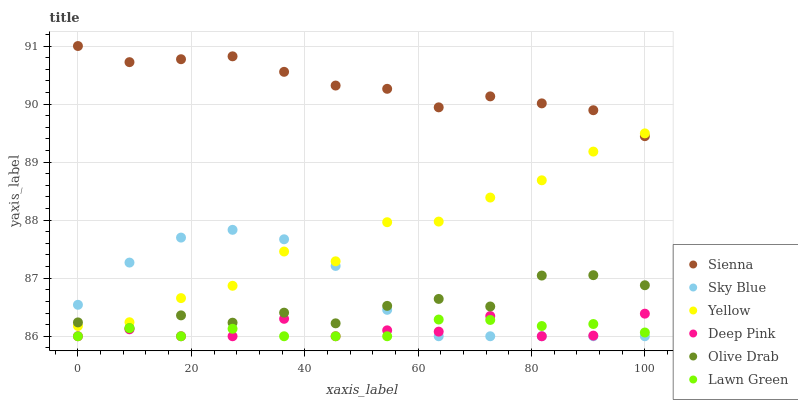Does Deep Pink have the minimum area under the curve?
Answer yes or no. Yes. Does Sienna have the maximum area under the curve?
Answer yes or no. Yes. Does Yellow have the minimum area under the curve?
Answer yes or no. No. Does Yellow have the maximum area under the curve?
Answer yes or no. No. Is Lawn Green the smoothest?
Answer yes or no. Yes. Is Yellow the roughest?
Answer yes or no. Yes. Is Deep Pink the smoothest?
Answer yes or no. No. Is Deep Pink the roughest?
Answer yes or no. No. Does Lawn Green have the lowest value?
Answer yes or no. Yes. Does Yellow have the lowest value?
Answer yes or no. No. Does Sienna have the highest value?
Answer yes or no. Yes. Does Deep Pink have the highest value?
Answer yes or no. No. Is Olive Drab less than Sienna?
Answer yes or no. Yes. Is Olive Drab greater than Deep Pink?
Answer yes or no. Yes. Does Lawn Green intersect Deep Pink?
Answer yes or no. Yes. Is Lawn Green less than Deep Pink?
Answer yes or no. No. Is Lawn Green greater than Deep Pink?
Answer yes or no. No. Does Olive Drab intersect Sienna?
Answer yes or no. No. 